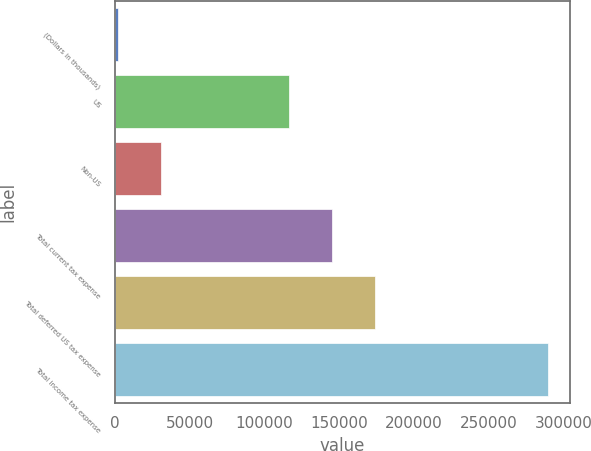<chart> <loc_0><loc_0><loc_500><loc_500><bar_chart><fcel>(Dollars in thousands)<fcel>US<fcel>Non-US<fcel>Total current tax expense<fcel>Total deferred US tax expense<fcel>Total income tax expense<nl><fcel>2013<fcel>116829<fcel>30782.3<fcel>145598<fcel>174368<fcel>289706<nl></chart> 